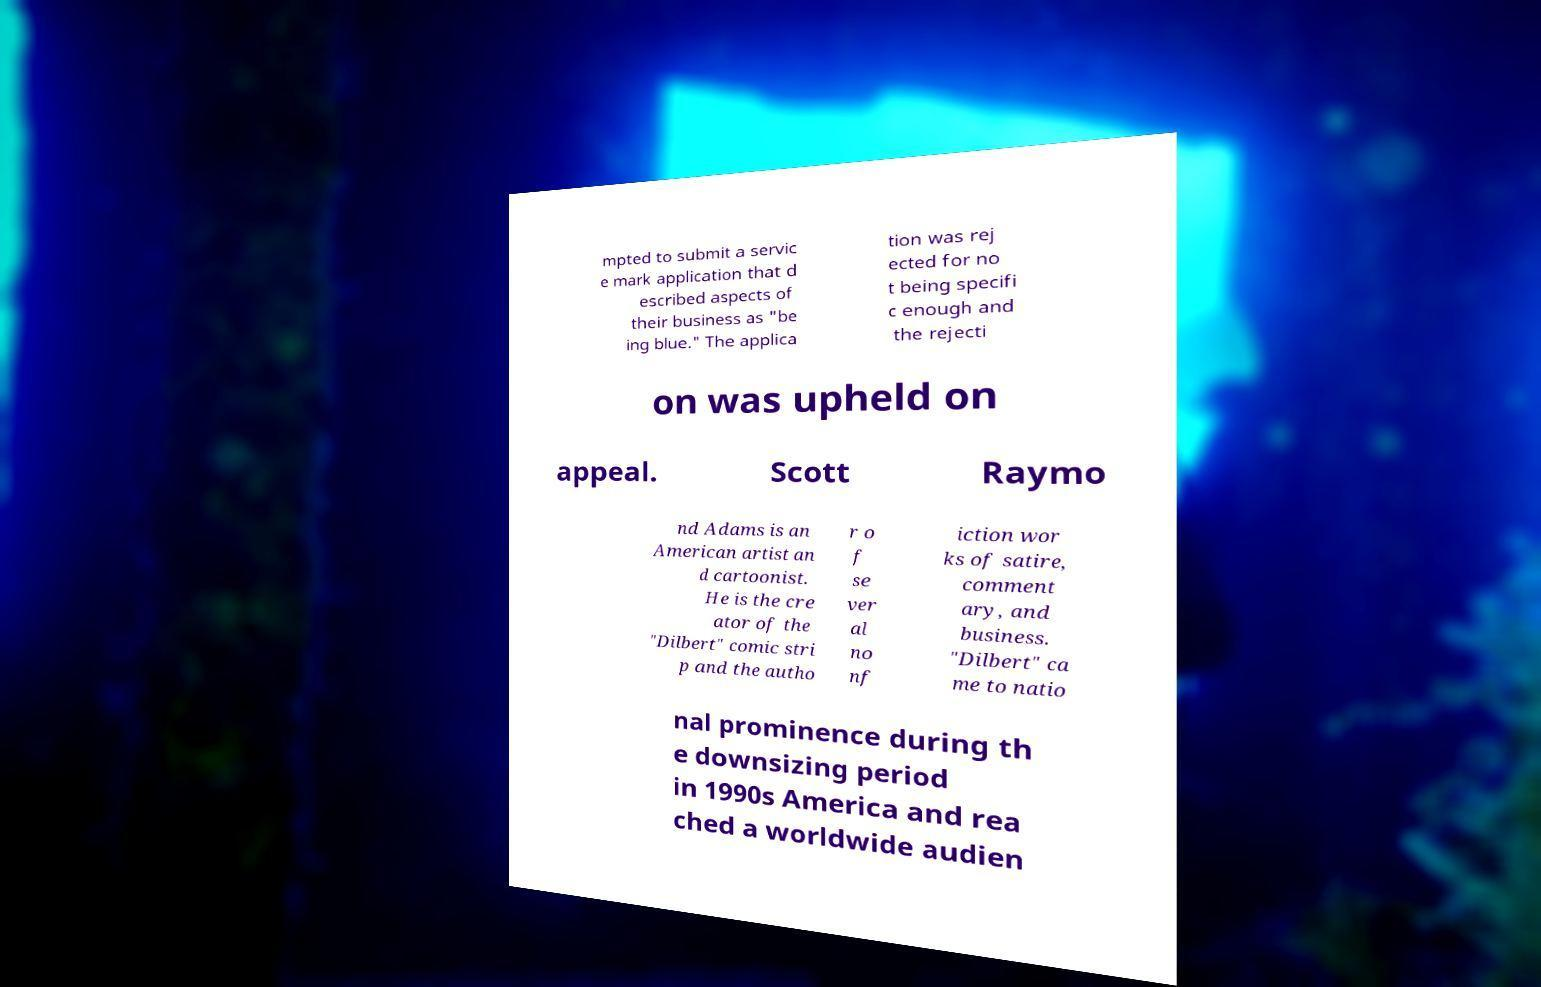What messages or text are displayed in this image? I need them in a readable, typed format. mpted to submit a servic e mark application that d escribed aspects of their business as "be ing blue." The applica tion was rej ected for no t being specifi c enough and the rejecti on was upheld on appeal. Scott Raymo nd Adams is an American artist an d cartoonist. He is the cre ator of the "Dilbert" comic stri p and the autho r o f se ver al no nf iction wor ks of satire, comment ary, and business. "Dilbert" ca me to natio nal prominence during th e downsizing period in 1990s America and rea ched a worldwide audien 